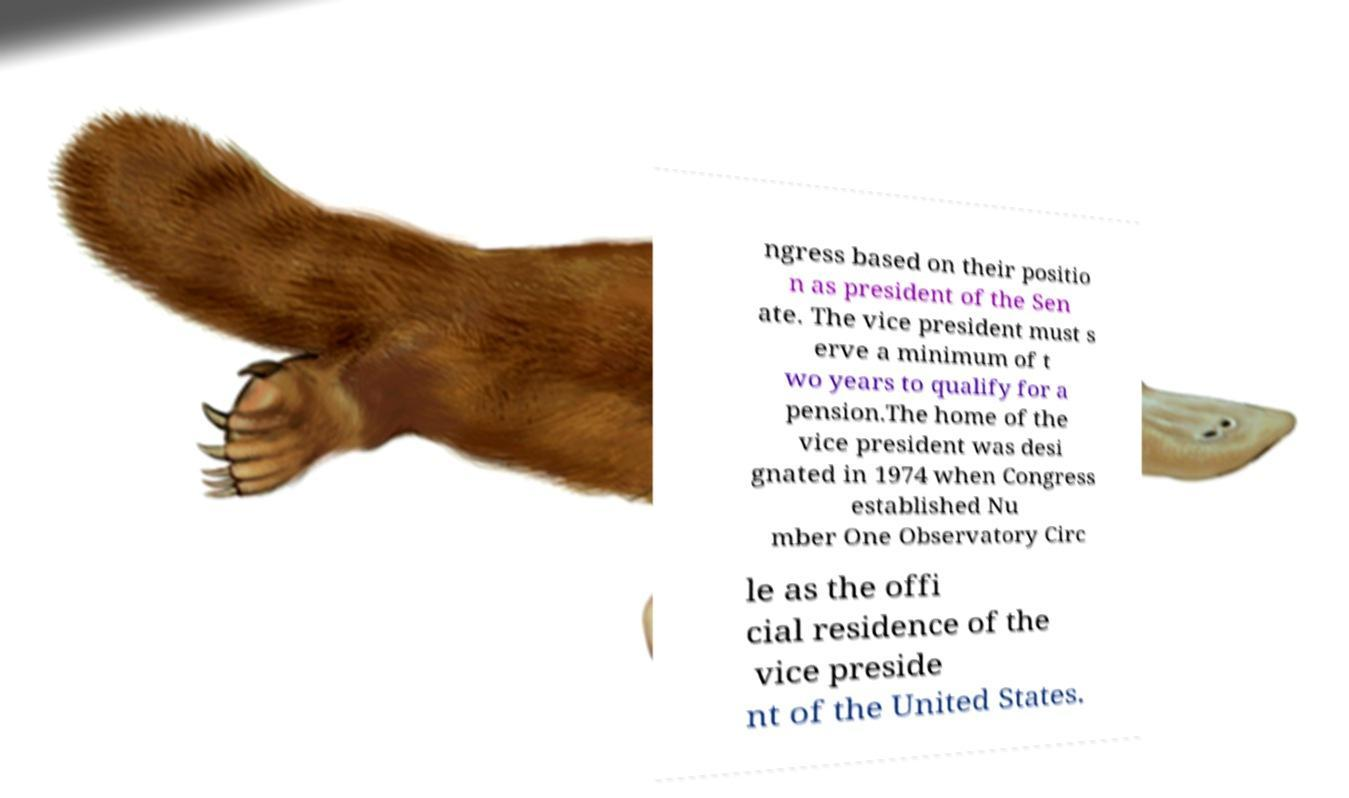Could you extract and type out the text from this image? ngress based on their positio n as president of the Sen ate. The vice president must s erve a minimum of t wo years to qualify for a pension.The home of the vice president was desi gnated in 1974 when Congress established Nu mber One Observatory Circ le as the offi cial residence of the vice preside nt of the United States. 